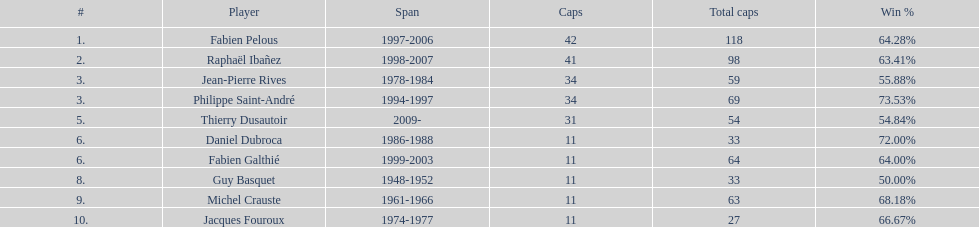What was the length of michel crauste's captaincy? 1961-1966. 